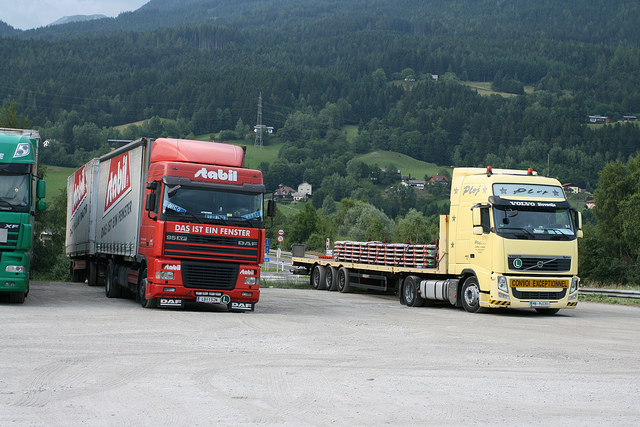<image>What highway route is on the vehicle? I don't know the highway route on the vehicle. It could be 61, route 66, 22, 150, or 60. What highway route is on the vehicle? I don't know what highway route is on the vehicle. It can be '61', 'route 66', '22', '150', '0', or 'parking lot'. 